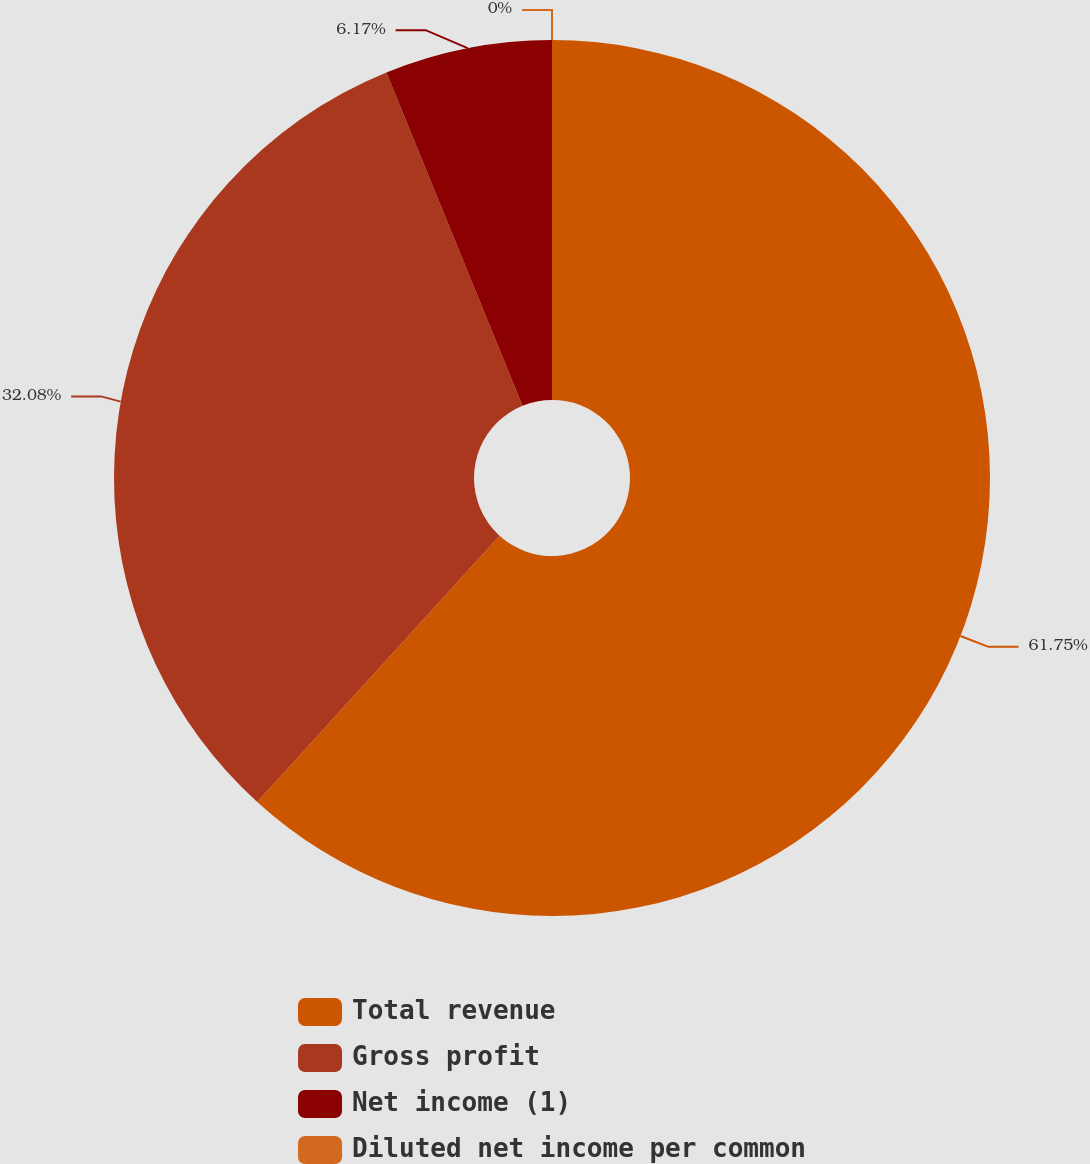Convert chart. <chart><loc_0><loc_0><loc_500><loc_500><pie_chart><fcel>Total revenue<fcel>Gross profit<fcel>Net income (1)<fcel>Diluted net income per common<nl><fcel>61.75%<fcel>32.08%<fcel>6.17%<fcel>0.0%<nl></chart> 